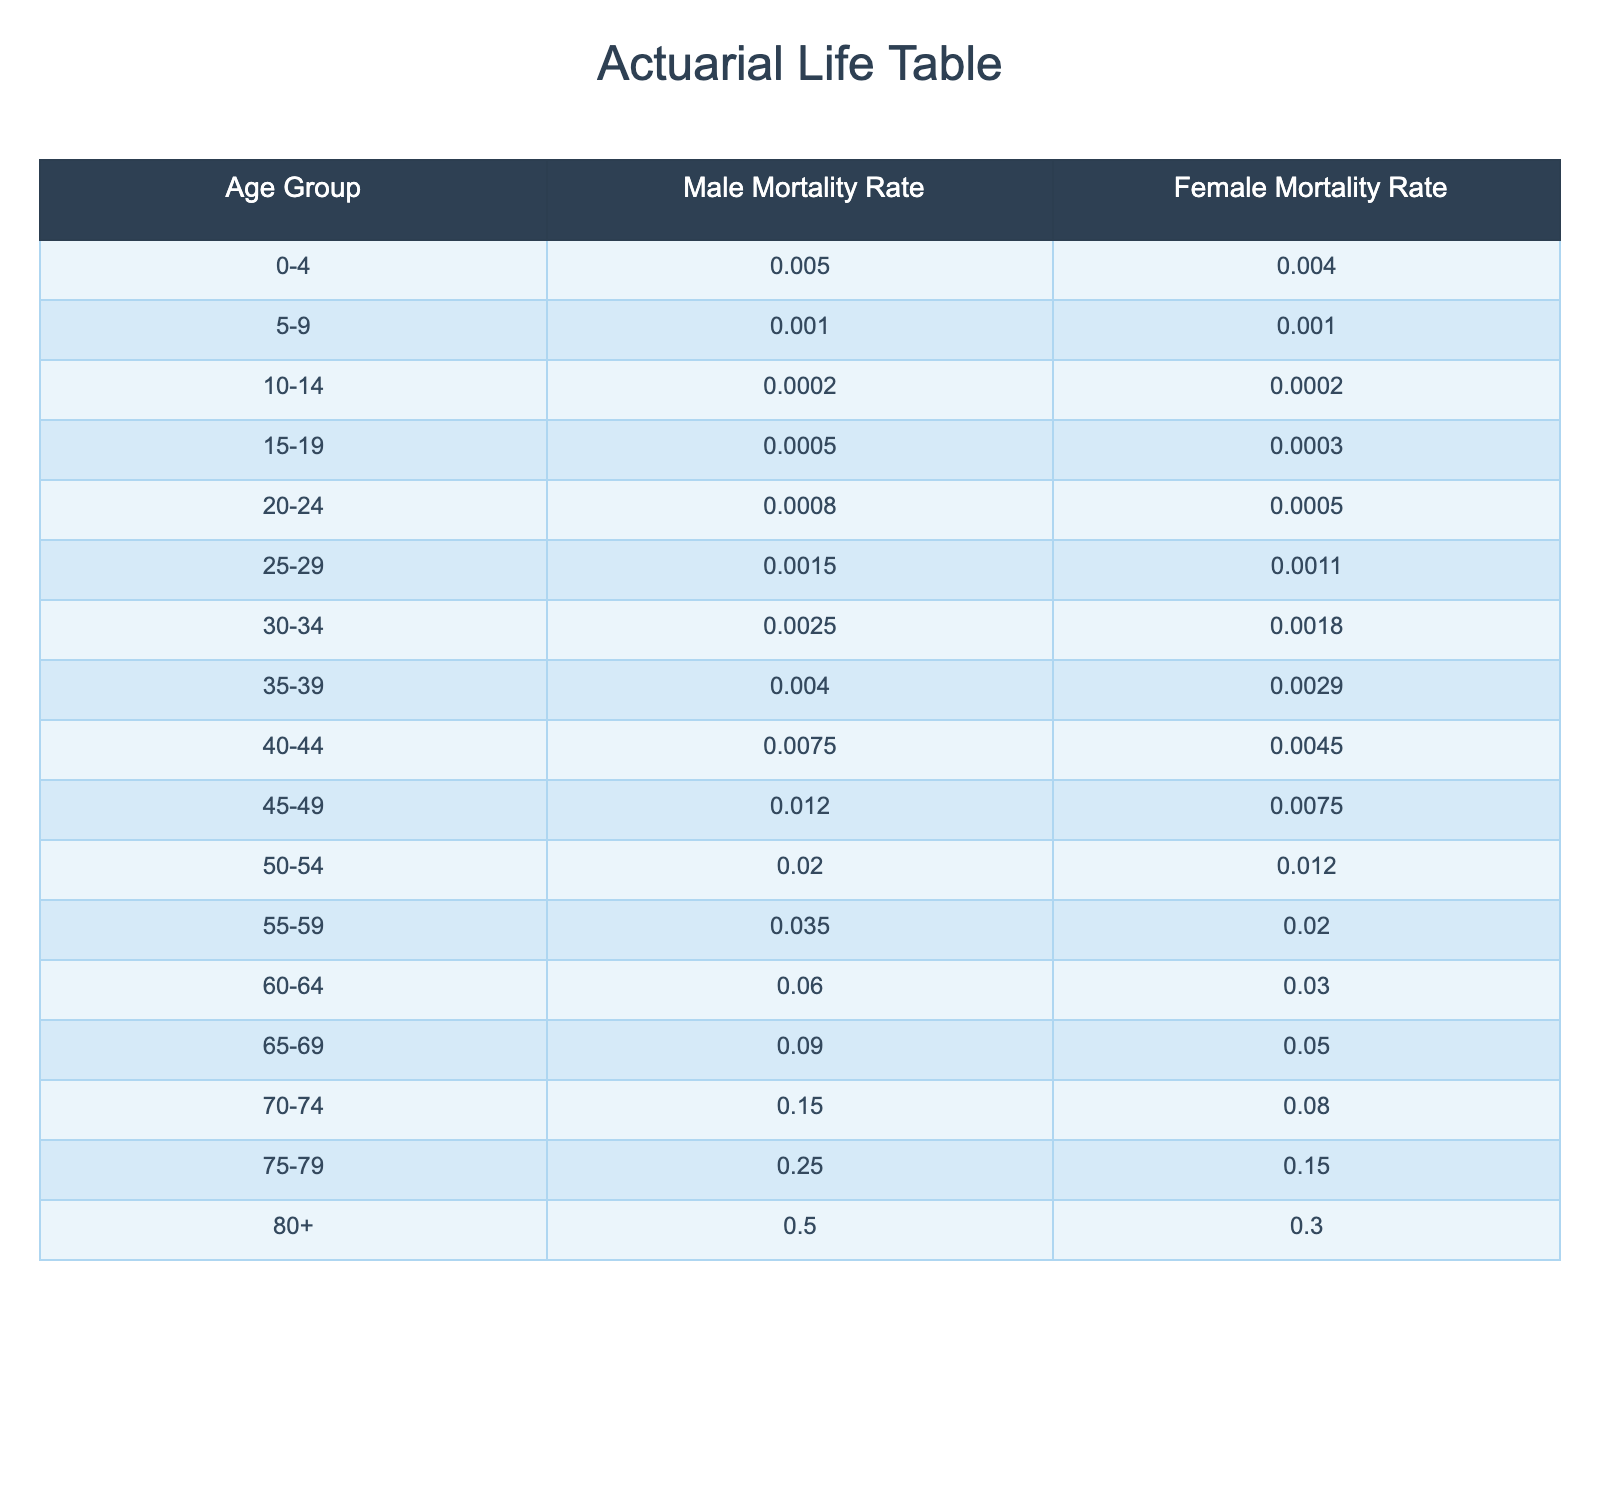What is the male mortality rate for the age group 50-54? The table lists the male mortality rate for the age group 50-54 as 0.0200.
Answer: 0.0200 What is the female mortality rate for the age group 35-39? According to the table, the female mortality rate for the age group 35-39 is 0.0029.
Answer: 0.0029 Which age group has the highest male mortality rate? By examining the table, the highest male mortality rate is found in the age group 80+, which is 0.5000.
Answer: 80+ How much higher is the male mortality rate for the age group 70-74 than for the age group 65-69? The male mortality rate for 70-74 is 0.1500 and for 65-69 is 0.0900. The difference is 0.1500 - 0.0900 = 0.0600.
Answer: 0.0600 Is the female mortality rate for the age group 0-4 greater than that for the age group 5-9? The female mortality rate for age 0-4 is 0.004 and for age 5-9 is 0.001. Since 0.004 is greater than 0.001, the answer is yes.
Answer: Yes What is the average mortality rate for males across all age groups? To find the average, we sum all male mortality rates: (0.005 + 0.001 + 0.0002 + 0.0005 + 0.0008 + 0.0015 + 0.0025 + 0.0040 + 0.0075 + 0.0120 + 0.0200 + 0.0350 + 0.0600 + 0.0900 + 0.1500 + 0.2500 + 0.5000) = 0.9135. There are 17 age groups, so the average is 0.9135 / 17 ≈ 0.0537.
Answer: 0.0537 Which gender has a higher mortality rate in the age group 75-79? The table lists the male mortality rate at 0.2500 and the female at 0.1500 for the age group 75-79. The male rate is greater, so yes, males have a higher rate.
Answer: Yes How does the male mortality rate for ages 60-64 compare to the rate for ages 55-59? For ages 60-64, the male mortality rate is 0.0600, and for ages 55-59, it is 0.0350. Comparing these values, 0.0600 is greater than 0.0350, indicating that 60-64 has a higher rate.
Answer: 0.0600 is higher than 0.0350 